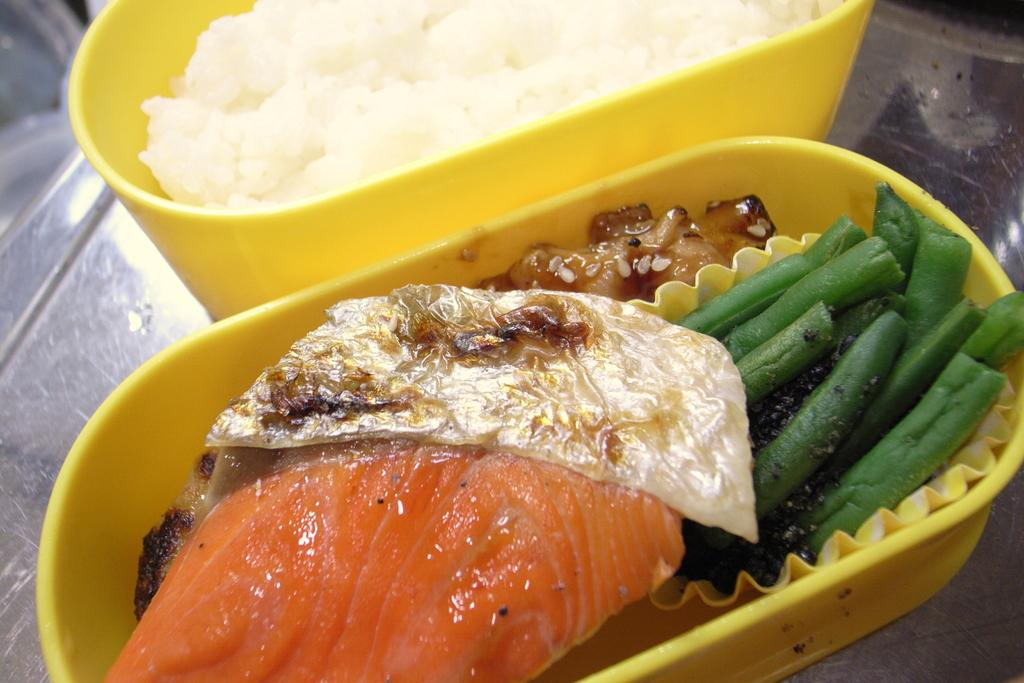What type of items can be seen in the image? There are food items in the image. How are the food items contained or organized? The food items are in boxes. Where are the boxes with food items located? The boxes are on a platform. What type of substance is being processed in the image? There is no indication of a substance being processed in the image; it only shows food items in boxes on a platform. 